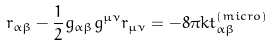<formula> <loc_0><loc_0><loc_500><loc_500>r _ { \alpha \beta } - \frac { 1 } { 2 } g _ { \alpha \beta } g ^ { \mu \nu } r _ { \mu \nu } = - 8 \pi k t _ { \alpha \beta } ^ { ( m i c r o ) }</formula> 